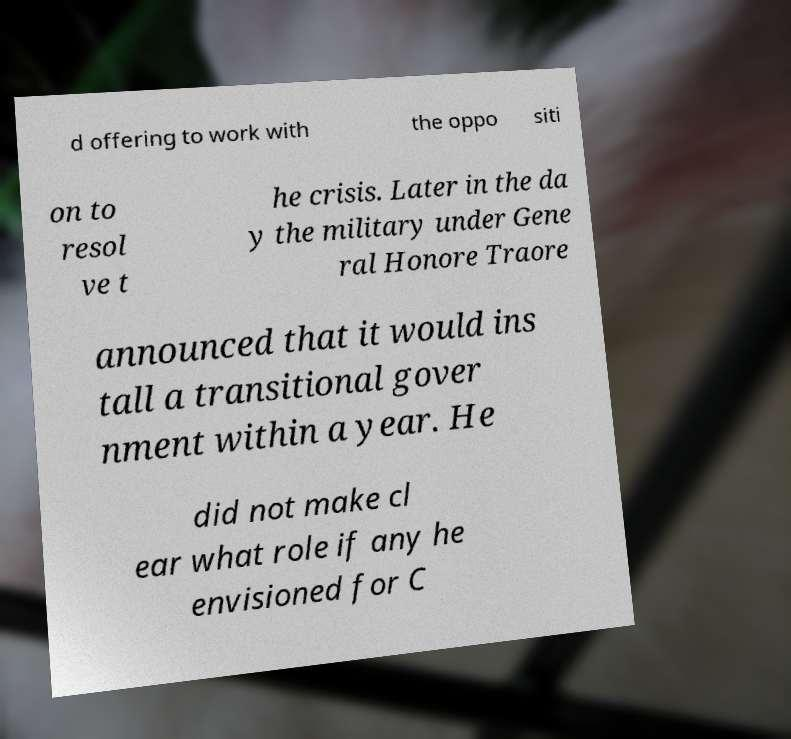What messages or text are displayed in this image? I need them in a readable, typed format. d offering to work with the oppo siti on to resol ve t he crisis. Later in the da y the military under Gene ral Honore Traore announced that it would ins tall a transitional gover nment within a year. He did not make cl ear what role if any he envisioned for C 